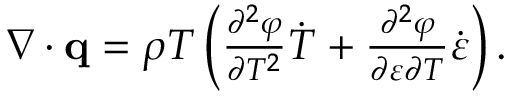<formula> <loc_0><loc_0><loc_500><loc_500>\begin{array} { r } { \nabla \cdot \mathbf q = \rho T \left ( \frac { \partial ^ { 2 } \varphi } { \partial T ^ { 2 } } \dot { T } + \frac { \partial ^ { 2 } \varphi } { \partial \boldsymbol \varepsilon \partial T } \dot { \boldsymbol \varepsilon } \right ) . } \end{array}</formula> 